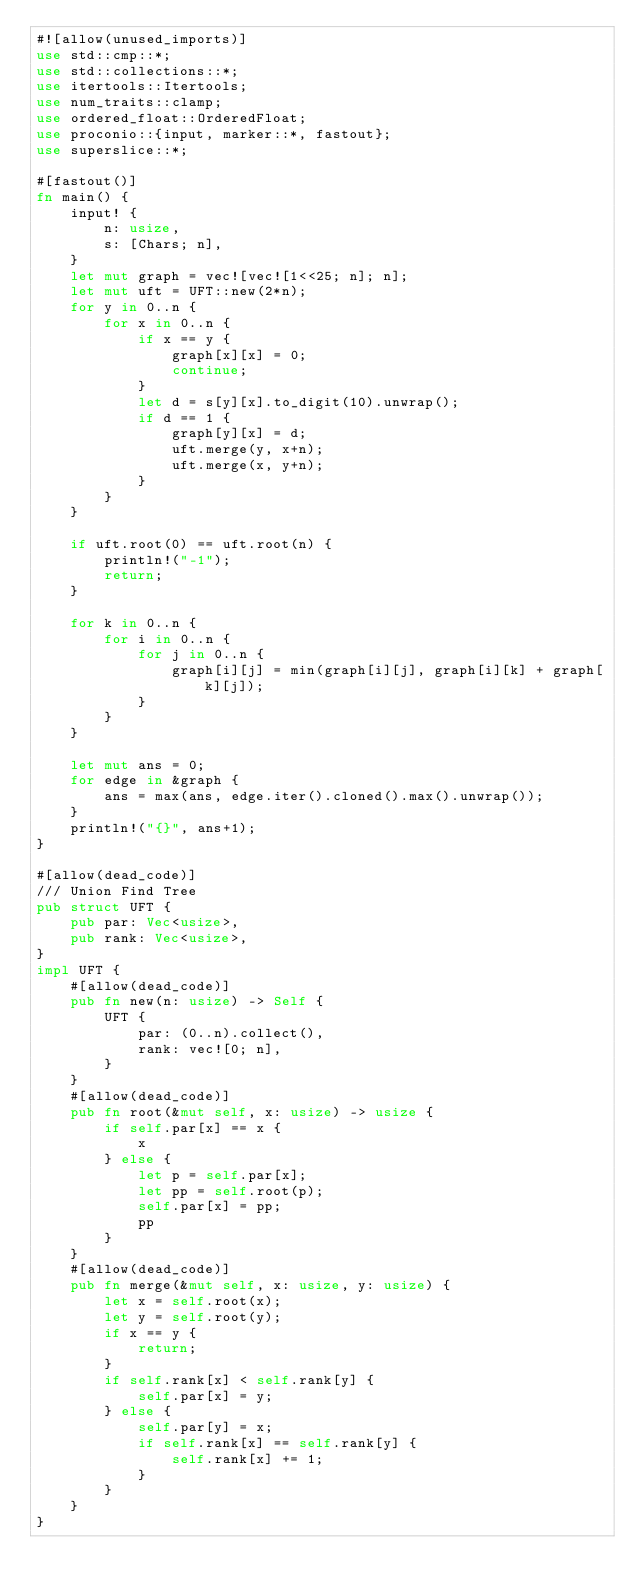Convert code to text. <code><loc_0><loc_0><loc_500><loc_500><_Rust_>#![allow(unused_imports)]
use std::cmp::*;
use std::collections::*;
use itertools::Itertools;
use num_traits::clamp;
use ordered_float::OrderedFloat;
use proconio::{input, marker::*, fastout};
use superslice::*;

#[fastout()]
fn main() {
    input! {
        n: usize,
        s: [Chars; n],
    }
    let mut graph = vec![vec![1<<25; n]; n];
    let mut uft = UFT::new(2*n);
    for y in 0..n {
        for x in 0..n {
            if x == y {
                graph[x][x] = 0;
                continue;
            }
            let d = s[y][x].to_digit(10).unwrap();
            if d == 1 {
                graph[y][x] = d;
                uft.merge(y, x+n);
                uft.merge(x, y+n);
            }
        }
    }

    if uft.root(0) == uft.root(n) {
        println!("-1");
        return;
    }

    for k in 0..n {
        for i in 0..n {
            for j in 0..n {
                graph[i][j] = min(graph[i][j], graph[i][k] + graph[k][j]);
            }
        }
    }

    let mut ans = 0;
    for edge in &graph {
        ans = max(ans, edge.iter().cloned().max().unwrap());
    }
    println!("{}", ans+1);
}

#[allow(dead_code)]
/// Union Find Tree
pub struct UFT {
    pub par: Vec<usize>,
    pub rank: Vec<usize>,
}
impl UFT {
    #[allow(dead_code)]
    pub fn new(n: usize) -> Self {
        UFT {
            par: (0..n).collect(),
            rank: vec![0; n],
        }
    }
    #[allow(dead_code)]
    pub fn root(&mut self, x: usize) -> usize {
        if self.par[x] == x {
            x
        } else {
            let p = self.par[x];
            let pp = self.root(p);
            self.par[x] = pp;
            pp
        }
    }
    #[allow(dead_code)]
    pub fn merge(&mut self, x: usize, y: usize) {
        let x = self.root(x);
        let y = self.root(y);
        if x == y {
            return;
        }
        if self.rank[x] < self.rank[y] {
            self.par[x] = y;
        } else {
            self.par[y] = x;
            if self.rank[x] == self.rank[y] {
                self.rank[x] += 1;
            }
        }
    }
}
</code> 